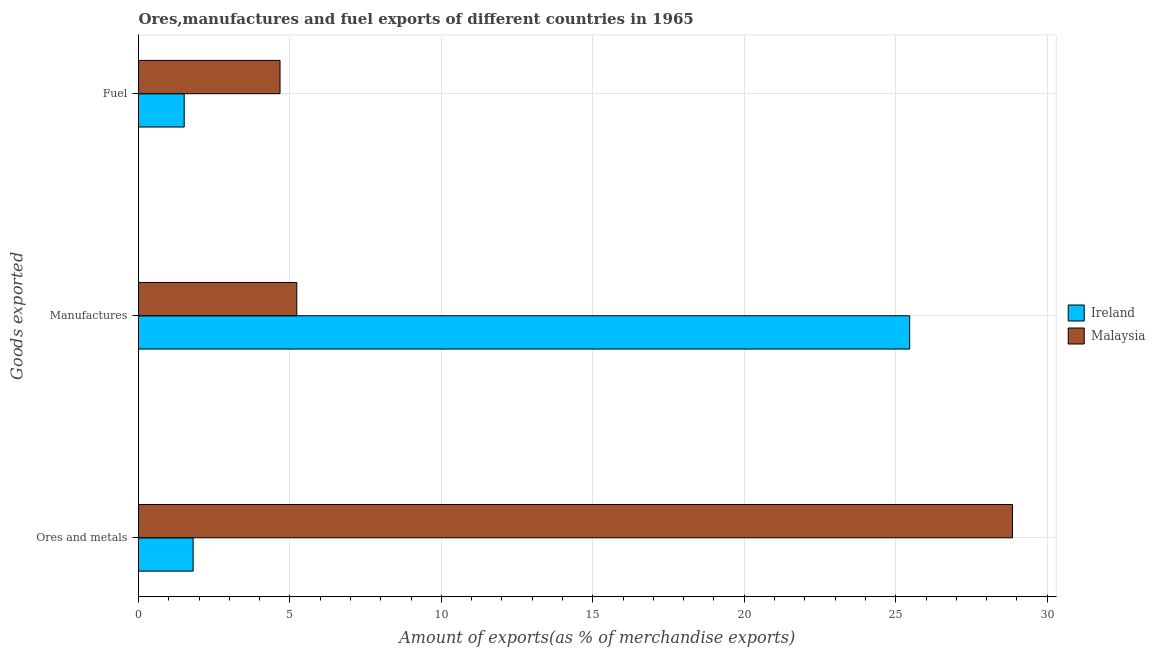How many groups of bars are there?
Give a very brief answer. 3. Are the number of bars per tick equal to the number of legend labels?
Provide a succinct answer. Yes. Are the number of bars on each tick of the Y-axis equal?
Ensure brevity in your answer.  Yes. How many bars are there on the 1st tick from the bottom?
Ensure brevity in your answer.  2. What is the label of the 1st group of bars from the top?
Provide a short and direct response. Fuel. What is the percentage of manufactures exports in Malaysia?
Your answer should be compact. 5.23. Across all countries, what is the maximum percentage of manufactures exports?
Make the answer very short. 25.46. Across all countries, what is the minimum percentage of manufactures exports?
Give a very brief answer. 5.23. In which country was the percentage of fuel exports maximum?
Ensure brevity in your answer.  Malaysia. In which country was the percentage of manufactures exports minimum?
Your answer should be compact. Malaysia. What is the total percentage of manufactures exports in the graph?
Keep it short and to the point. 30.69. What is the difference between the percentage of fuel exports in Ireland and that in Malaysia?
Your answer should be compact. -3.16. What is the difference between the percentage of fuel exports in Ireland and the percentage of manufactures exports in Malaysia?
Ensure brevity in your answer.  -3.72. What is the average percentage of fuel exports per country?
Your answer should be very brief. 3.09. What is the difference between the percentage of ores and metals exports and percentage of fuel exports in Malaysia?
Your answer should be compact. 24.18. What is the ratio of the percentage of fuel exports in Ireland to that in Malaysia?
Provide a short and direct response. 0.32. Is the percentage of ores and metals exports in Malaysia less than that in Ireland?
Provide a short and direct response. No. What is the difference between the highest and the second highest percentage of fuel exports?
Provide a succinct answer. 3.16. What is the difference between the highest and the lowest percentage of manufactures exports?
Your answer should be very brief. 20.24. What does the 1st bar from the top in Ores and metals represents?
Make the answer very short. Malaysia. What does the 2nd bar from the bottom in Ores and metals represents?
Provide a succinct answer. Malaysia. How many countries are there in the graph?
Provide a succinct answer. 2. Are the values on the major ticks of X-axis written in scientific E-notation?
Ensure brevity in your answer.  No. Does the graph contain grids?
Keep it short and to the point. Yes. Where does the legend appear in the graph?
Ensure brevity in your answer.  Center right. How are the legend labels stacked?
Your answer should be very brief. Vertical. What is the title of the graph?
Keep it short and to the point. Ores,manufactures and fuel exports of different countries in 1965. What is the label or title of the X-axis?
Make the answer very short. Amount of exports(as % of merchandise exports). What is the label or title of the Y-axis?
Offer a terse response. Goods exported. What is the Amount of exports(as % of merchandise exports) in Ireland in Ores and metals?
Your answer should be very brief. 1.8. What is the Amount of exports(as % of merchandise exports) of Malaysia in Ores and metals?
Provide a short and direct response. 28.86. What is the Amount of exports(as % of merchandise exports) of Ireland in Manufactures?
Offer a terse response. 25.46. What is the Amount of exports(as % of merchandise exports) in Malaysia in Manufactures?
Provide a short and direct response. 5.23. What is the Amount of exports(as % of merchandise exports) in Ireland in Fuel?
Your response must be concise. 1.51. What is the Amount of exports(as % of merchandise exports) of Malaysia in Fuel?
Your response must be concise. 4.67. Across all Goods exported, what is the maximum Amount of exports(as % of merchandise exports) in Ireland?
Your response must be concise. 25.46. Across all Goods exported, what is the maximum Amount of exports(as % of merchandise exports) of Malaysia?
Provide a succinct answer. 28.86. Across all Goods exported, what is the minimum Amount of exports(as % of merchandise exports) of Ireland?
Make the answer very short. 1.51. Across all Goods exported, what is the minimum Amount of exports(as % of merchandise exports) in Malaysia?
Your answer should be very brief. 4.67. What is the total Amount of exports(as % of merchandise exports) in Ireland in the graph?
Provide a short and direct response. 28.77. What is the total Amount of exports(as % of merchandise exports) of Malaysia in the graph?
Your answer should be compact. 38.75. What is the difference between the Amount of exports(as % of merchandise exports) of Ireland in Ores and metals and that in Manufactures?
Give a very brief answer. -23.66. What is the difference between the Amount of exports(as % of merchandise exports) in Malaysia in Ores and metals and that in Manufactures?
Offer a terse response. 23.63. What is the difference between the Amount of exports(as % of merchandise exports) in Ireland in Ores and metals and that in Fuel?
Provide a succinct answer. 0.3. What is the difference between the Amount of exports(as % of merchandise exports) of Malaysia in Ores and metals and that in Fuel?
Your answer should be very brief. 24.18. What is the difference between the Amount of exports(as % of merchandise exports) of Ireland in Manufactures and that in Fuel?
Give a very brief answer. 23.95. What is the difference between the Amount of exports(as % of merchandise exports) of Malaysia in Manufactures and that in Fuel?
Give a very brief answer. 0.55. What is the difference between the Amount of exports(as % of merchandise exports) in Ireland in Ores and metals and the Amount of exports(as % of merchandise exports) in Malaysia in Manufactures?
Your answer should be compact. -3.42. What is the difference between the Amount of exports(as % of merchandise exports) in Ireland in Ores and metals and the Amount of exports(as % of merchandise exports) in Malaysia in Fuel?
Make the answer very short. -2.87. What is the difference between the Amount of exports(as % of merchandise exports) in Ireland in Manufactures and the Amount of exports(as % of merchandise exports) in Malaysia in Fuel?
Make the answer very short. 20.79. What is the average Amount of exports(as % of merchandise exports) in Ireland per Goods exported?
Provide a succinct answer. 9.59. What is the average Amount of exports(as % of merchandise exports) in Malaysia per Goods exported?
Your answer should be compact. 12.92. What is the difference between the Amount of exports(as % of merchandise exports) of Ireland and Amount of exports(as % of merchandise exports) of Malaysia in Ores and metals?
Your answer should be very brief. -27.05. What is the difference between the Amount of exports(as % of merchandise exports) of Ireland and Amount of exports(as % of merchandise exports) of Malaysia in Manufactures?
Your answer should be very brief. 20.24. What is the difference between the Amount of exports(as % of merchandise exports) of Ireland and Amount of exports(as % of merchandise exports) of Malaysia in Fuel?
Offer a very short reply. -3.16. What is the ratio of the Amount of exports(as % of merchandise exports) of Ireland in Ores and metals to that in Manufactures?
Your response must be concise. 0.07. What is the ratio of the Amount of exports(as % of merchandise exports) of Malaysia in Ores and metals to that in Manufactures?
Offer a terse response. 5.52. What is the ratio of the Amount of exports(as % of merchandise exports) in Ireland in Ores and metals to that in Fuel?
Your response must be concise. 1.2. What is the ratio of the Amount of exports(as % of merchandise exports) in Malaysia in Ores and metals to that in Fuel?
Provide a succinct answer. 6.18. What is the ratio of the Amount of exports(as % of merchandise exports) in Ireland in Manufactures to that in Fuel?
Provide a succinct answer. 16.88. What is the ratio of the Amount of exports(as % of merchandise exports) of Malaysia in Manufactures to that in Fuel?
Your answer should be very brief. 1.12. What is the difference between the highest and the second highest Amount of exports(as % of merchandise exports) in Ireland?
Your answer should be very brief. 23.66. What is the difference between the highest and the second highest Amount of exports(as % of merchandise exports) of Malaysia?
Give a very brief answer. 23.63. What is the difference between the highest and the lowest Amount of exports(as % of merchandise exports) in Ireland?
Offer a terse response. 23.95. What is the difference between the highest and the lowest Amount of exports(as % of merchandise exports) in Malaysia?
Provide a short and direct response. 24.18. 